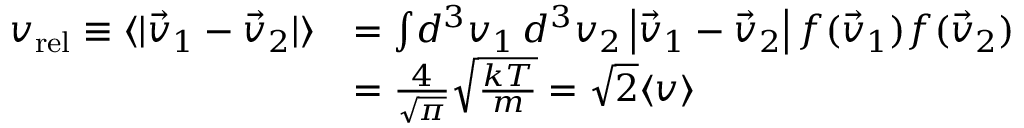Convert formula to latex. <formula><loc_0><loc_0><loc_500><loc_500>{ \begin{array} { r l } { v _ { r e l } \equiv \langle | { \vec { v } } _ { 1 } - { \vec { v } } _ { 2 } | \rangle } & { = \int \, d ^ { 3 } v _ { 1 } \, d ^ { 3 } v _ { 2 } \left | { \vec { v } } _ { 1 } - { \vec { v } } _ { 2 } \right | f ( { \vec { v } } _ { 1 } ) f ( { \vec { v } } _ { 2 } ) } \\ & { = { \frac { 4 } { \sqrt { \pi } } } { \sqrt { \frac { k T } { m } } } = { \sqrt { 2 } } \langle v \rangle } \end{array} }</formula> 